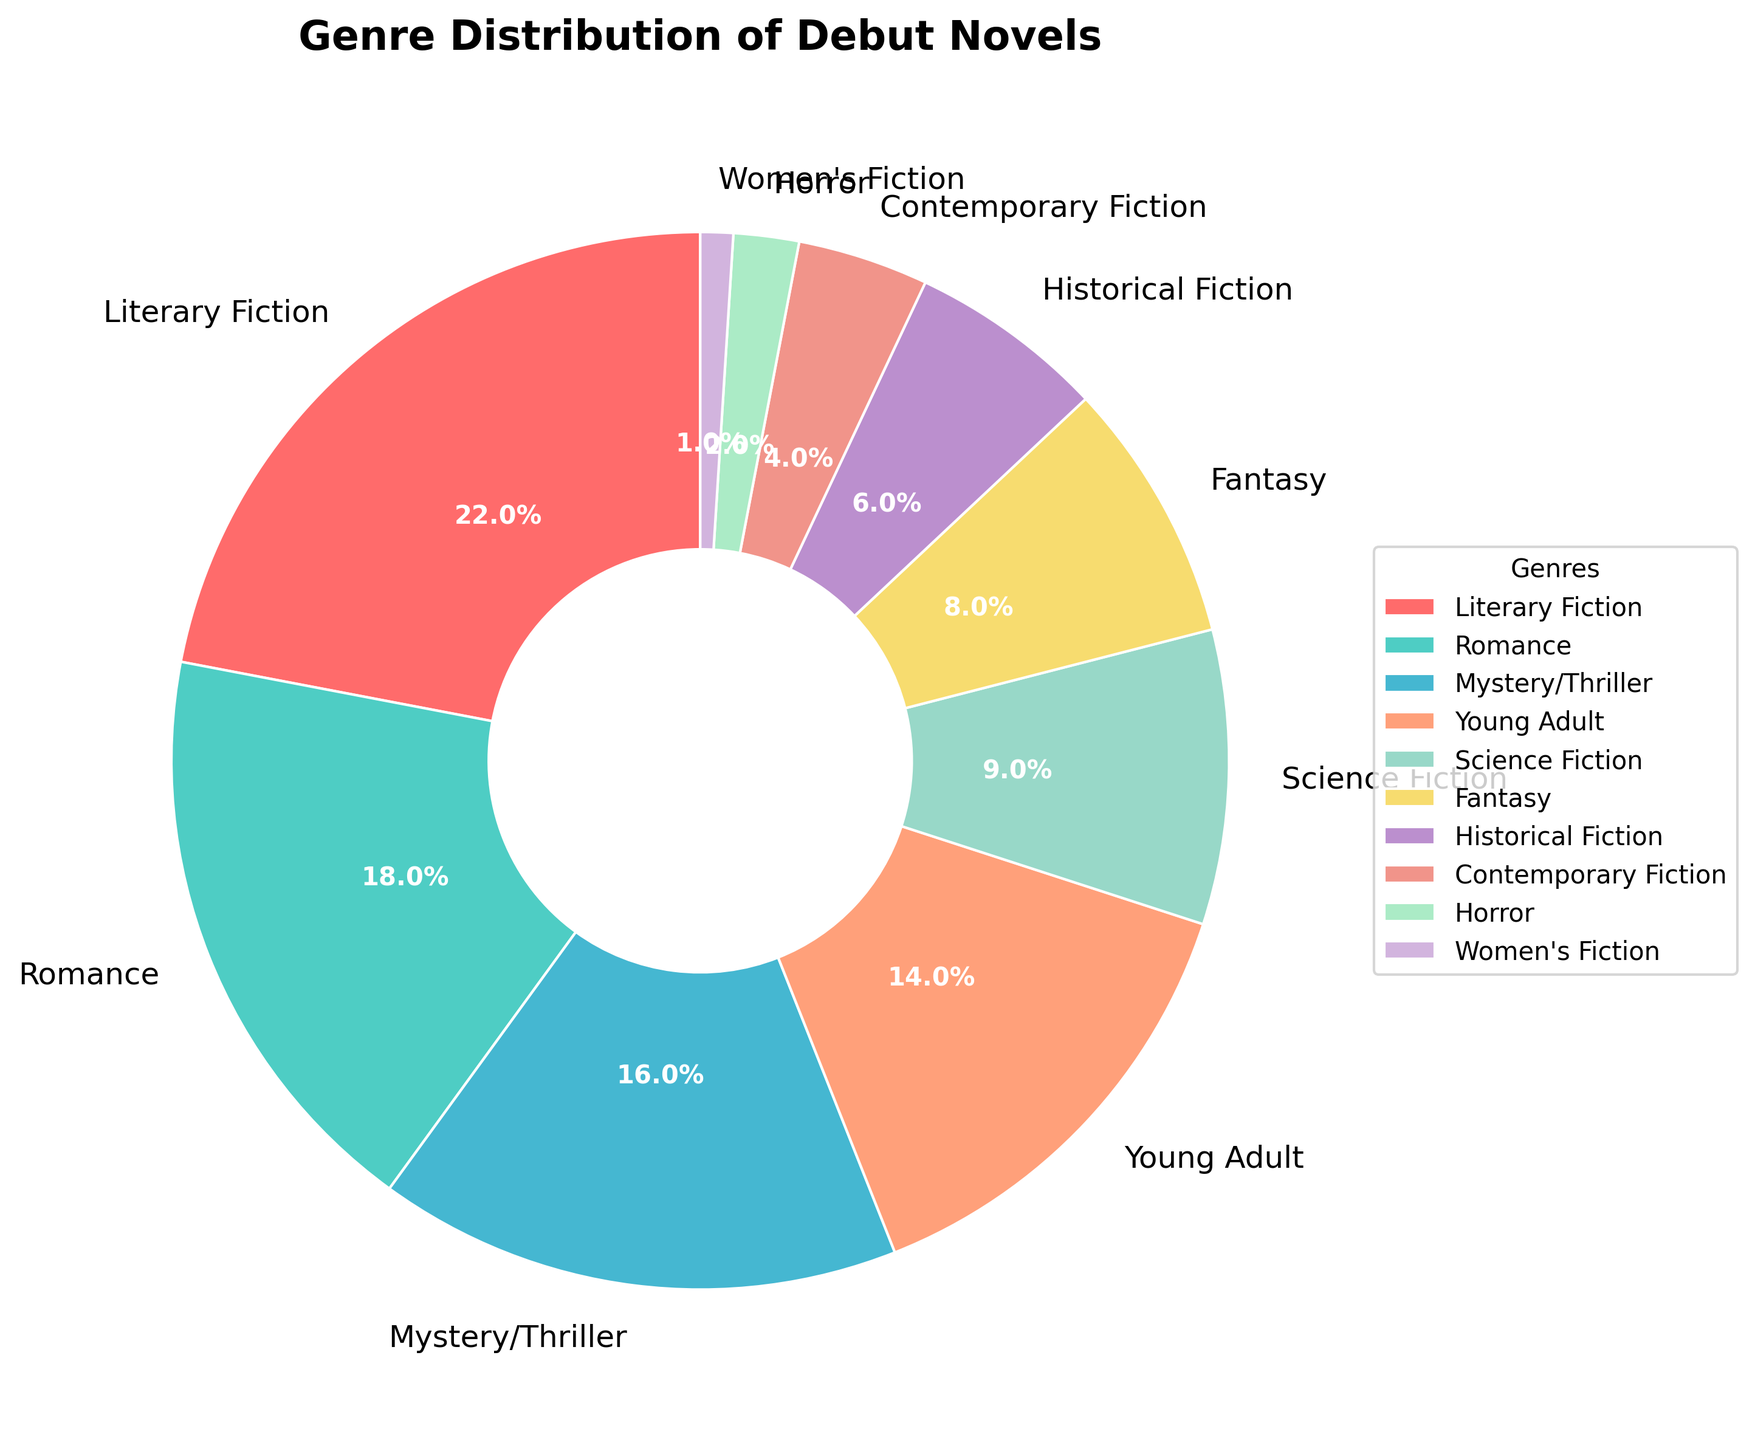What genre constitutes the largest portion of debut novels? By looking at the pie chart, the slice representing Literary Fiction is the largest, indicating it has the highest percentage.
Answer: Literary Fiction Which genre represents a smaller portion of debut novels, Romance or Fantasy? Comparing the slices for Romance and Fantasy, the Romance slice is larger than the Fantasy one, indicating Fantasy has a smaller percentage.
Answer: Fantasy What is the combined percentage of Science Fiction, Fantasy, and Historical Fiction debut novels? To find the combined percentage, sum the individual percentages: Science Fiction (9%) + Fantasy (8%) + Historical Fiction (6%) = 23%.
Answer: 23% How much more percentage do Literary Fiction debut novels have compared to Horror debut novels? Subtract the percentage of Horror from Literary Fiction: 22% (Literary Fiction) - 2% (Horror) = 20%.
Answer: 20% Which genre has a percentage closest to 10%? The genre with a percentage closest to 10% is Science Fiction with 9%.
Answer: Science Fiction Are there more debut novels in the Mystery/Thriller or Young Adult genre? Comparing the slices for Mystery/Thriller and Young Adult, the Mystery/Thriller slice is slightly larger, indicating a higher percentage.
Answer: Mystery/Thriller By how much does Contemporary Fiction's percentage exceed Women's Fiction's percentage? Subtract Women's Fiction's percentage from Contemporary Fiction's percentage: 4% (Contemporary Fiction) - 1% (Women's Fiction) = 3%.
Answer: 3% What is the total percentage of debut novels falling under genres with less than 10% each? Sum the percentages of genres with less than 10%: Science Fiction (9%) + Fantasy (8%) + Historical Fiction (6%) + Contemporary Fiction (4%) + Horror (2%) + Women's Fiction (1%) = 30%.
Answer: 30% If you had to choose between Romance and Mystery/Thriller based on their debut novel percentages, which genre has a higher percentage? The Romance genre has a higher percentage (18%) compared to Mystery/Thriller (16%).
Answer: Romance What's the percentage difference between Young Adult and Historical Fiction debut novels? Subtract the percentage of Historical Fiction from Young Adult: 14% (Young Adult) - 6% (Historical Fiction) = 8%.
Answer: 8% 